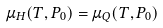Convert formula to latex. <formula><loc_0><loc_0><loc_500><loc_500>\mu _ { H } ( T , P _ { 0 } ) = \mu _ { Q } ( T , P _ { 0 } ) \,</formula> 